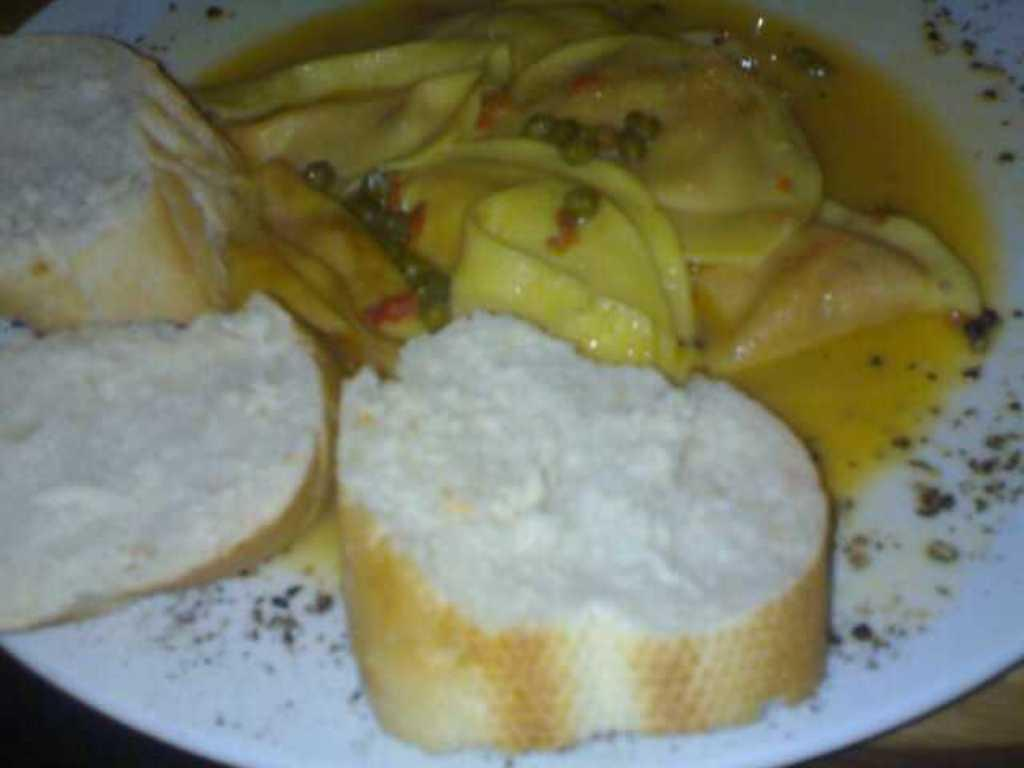What is located in the center of the image? There is a plate in the center of the image. What is on the plate? There is food on the plate. How many girls are sitting at the table with the plate of food? There is no information about girls or a table in the image; it only shows a plate with food. 